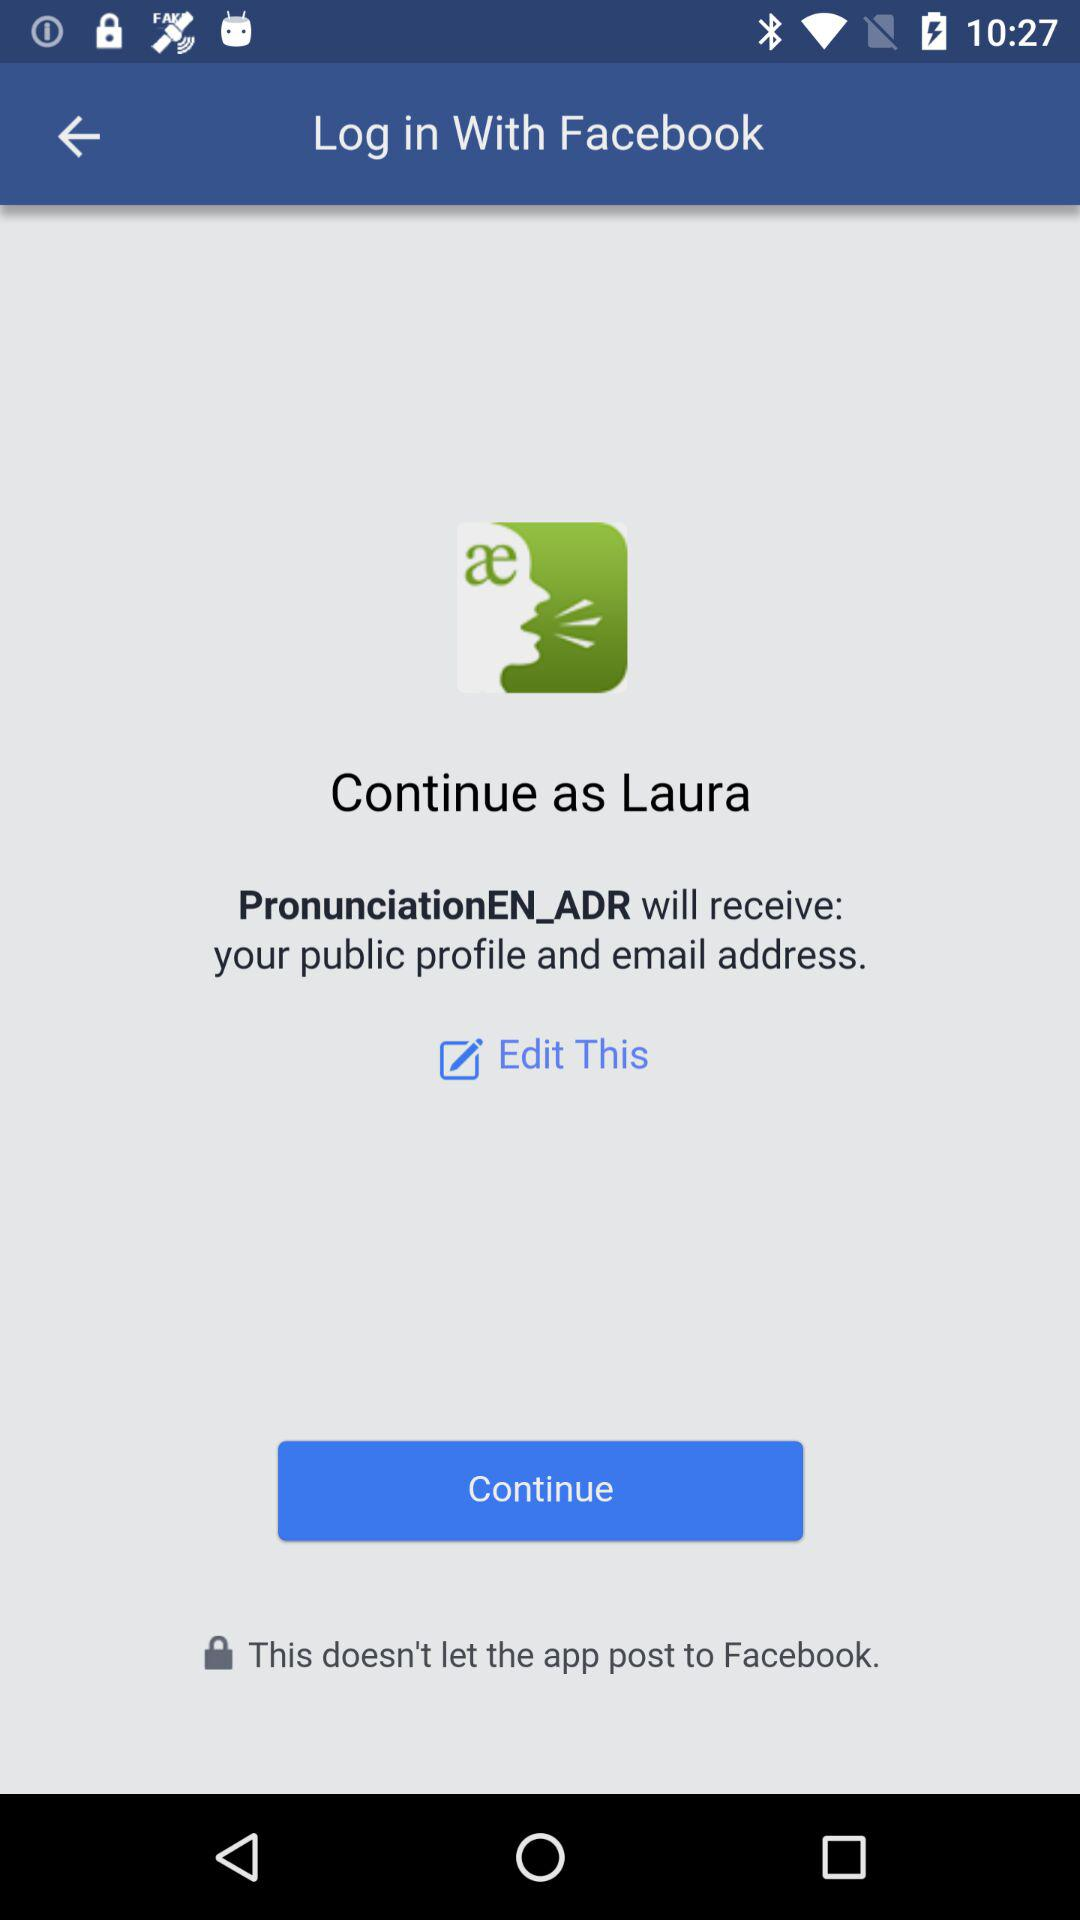What application is asking for permission? The application asking for the permission is "PronunciationEN_ADR". 